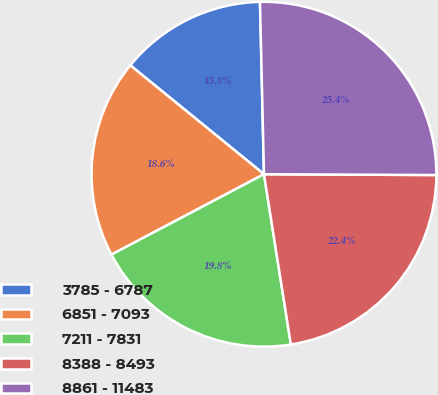Convert chart to OTSL. <chart><loc_0><loc_0><loc_500><loc_500><pie_chart><fcel>3785 - 6787<fcel>6851 - 7093<fcel>7211 - 7831<fcel>8388 - 8493<fcel>8861 - 11483<nl><fcel>13.75%<fcel>18.6%<fcel>19.77%<fcel>22.43%<fcel>25.44%<nl></chart> 